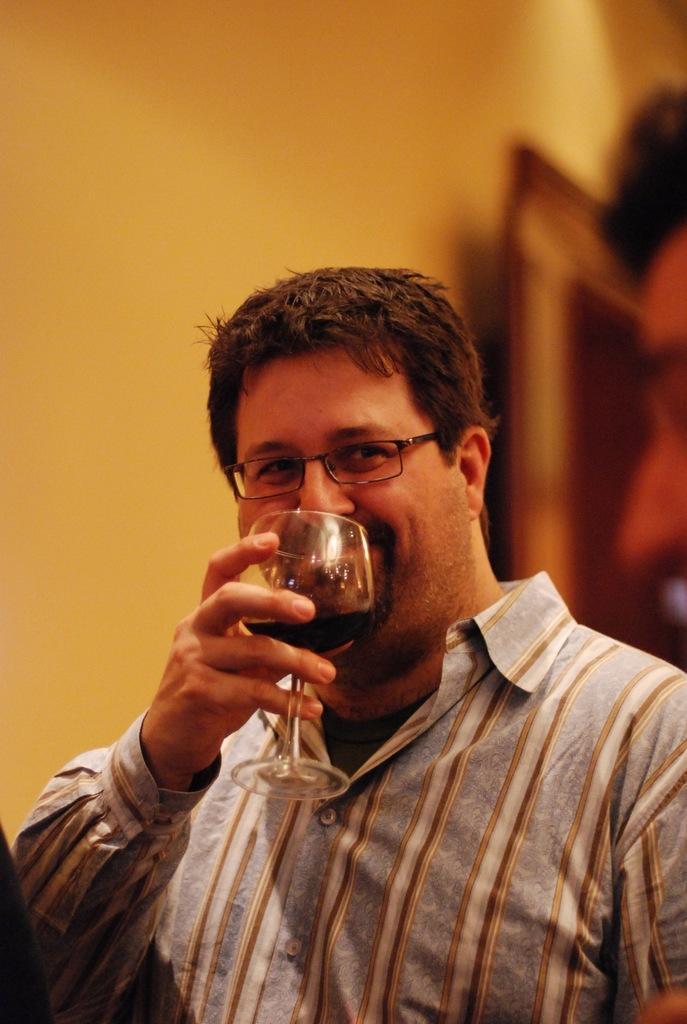In one or two sentences, can you explain what this image depicts? In this picture we can see man wore spectacle holding glass in his hand with drink in it and smiling. 